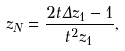Convert formula to latex. <formula><loc_0><loc_0><loc_500><loc_500>z _ { N } = \frac { 2 t \Delta z _ { 1 } - 1 } { t ^ { 2 } z _ { 1 } } ,</formula> 